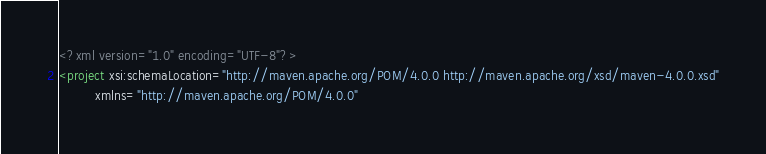<code> <loc_0><loc_0><loc_500><loc_500><_XML_><?xml version="1.0" encoding="UTF-8"?>
<project xsi:schemaLocation="http://maven.apache.org/POM/4.0.0 http://maven.apache.org/xsd/maven-4.0.0.xsd"
         xmlns="http://maven.apache.org/POM/4.0.0"</code> 